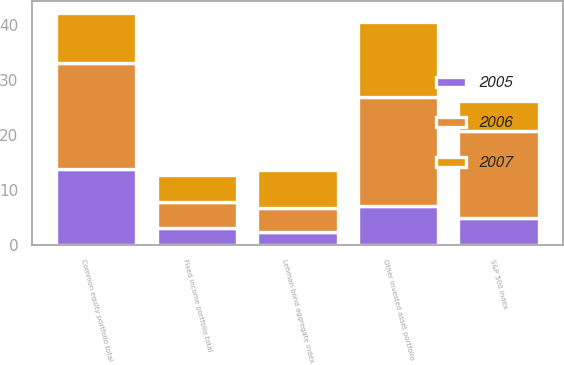<chart> <loc_0><loc_0><loc_500><loc_500><stacked_bar_chart><ecel><fcel>Fixed income portfolio total<fcel>Lehman bond aggregate index<fcel>Common equity portfolio total<fcel>S&P 500 index<fcel>Other invested asset portfolio<nl><fcel>2007<fcel>5<fcel>7<fcel>9.2<fcel>5.5<fcel>13.5<nl><fcel>2006<fcel>4.6<fcel>4.3<fcel>19.2<fcel>15.8<fcel>19.8<nl><fcel>2005<fcel>3.2<fcel>2.4<fcel>13.8<fcel>4.9<fcel>7.2<nl></chart> 